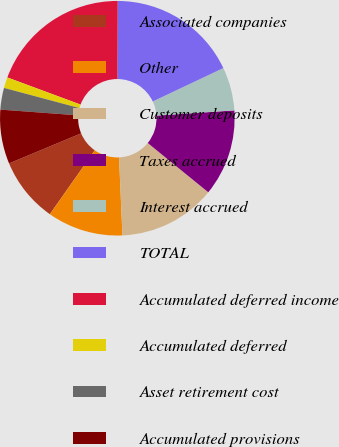Convert chart to OTSL. <chart><loc_0><loc_0><loc_500><loc_500><pie_chart><fcel>Associated companies<fcel>Other<fcel>Customer deposits<fcel>Taxes accrued<fcel>Interest accrued<fcel>TOTAL<fcel>Accumulated deferred income<fcel>Accumulated deferred<fcel>Asset retirement cost<fcel>Accumulated provisions<nl><fcel>8.96%<fcel>10.45%<fcel>13.43%<fcel>11.94%<fcel>5.97%<fcel>17.91%<fcel>19.4%<fcel>1.49%<fcel>2.99%<fcel>7.46%<nl></chart> 